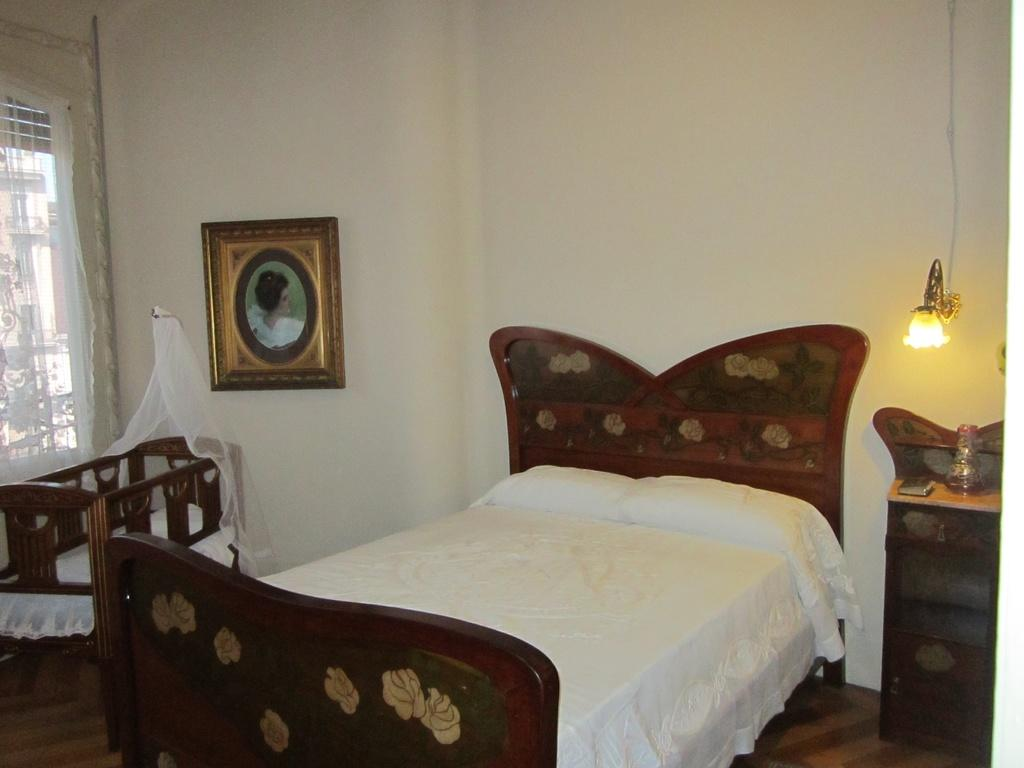What is the color of the wall in the image? The wall in the image is white. What can be seen hanging on the wall? There is a photo frame in the image. What type of furniture is present in the image? There is a bed and a table in the image. What is on the table in the image? There is a book on the table. Where is the light located in the image? The light is on the right side of the image. How many pets are visible in the image? There are no pets present in the image. What type of group or team is shown in the image? There is no group or team depicted in the image; it features a room with a bed, table, book, photo frame, and light. 